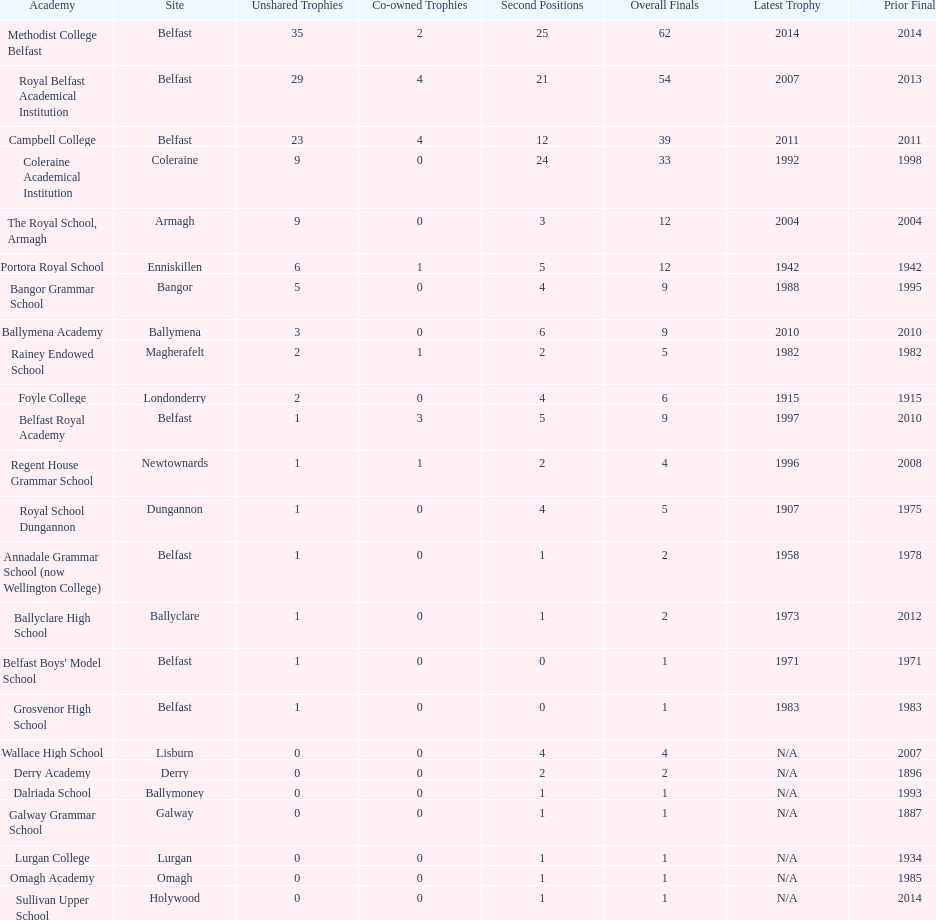What was the last year that the regent house grammar school won a title? 1996. 